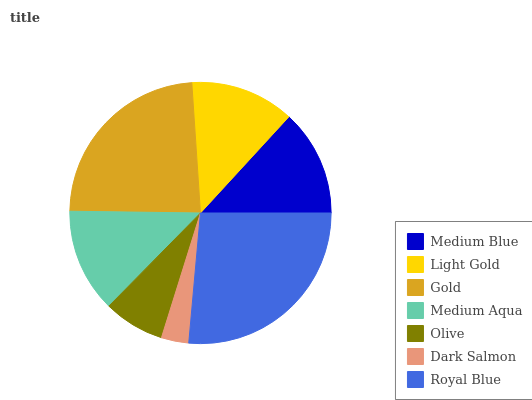Is Dark Salmon the minimum?
Answer yes or no. Yes. Is Royal Blue the maximum?
Answer yes or no. Yes. Is Light Gold the minimum?
Answer yes or no. No. Is Light Gold the maximum?
Answer yes or no. No. Is Medium Blue greater than Light Gold?
Answer yes or no. Yes. Is Light Gold less than Medium Blue?
Answer yes or no. Yes. Is Light Gold greater than Medium Blue?
Answer yes or no. No. Is Medium Blue less than Light Gold?
Answer yes or no. No. Is Light Gold the high median?
Answer yes or no. Yes. Is Light Gold the low median?
Answer yes or no. Yes. Is Medium Aqua the high median?
Answer yes or no. No. Is Dark Salmon the low median?
Answer yes or no. No. 